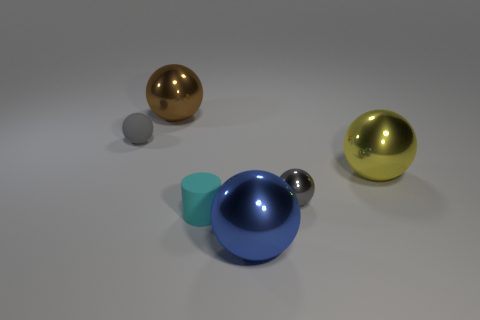There is a metallic ball that is the same color as the rubber ball; what size is it?
Make the answer very short. Small. Are there fewer big yellow metal spheres than small gray shiny cylinders?
Your answer should be compact. No. There is a metal object that is behind the object that is left of the brown sphere; are there any gray matte objects that are right of it?
Give a very brief answer. No. What number of metal objects are tiny cyan cubes or large things?
Give a very brief answer. 3. Do the rubber ball and the small metal sphere have the same color?
Make the answer very short. Yes. How many yellow metallic objects are on the left side of the big yellow thing?
Ensure brevity in your answer.  0. How many metal objects are both to the left of the tiny metal ball and behind the cyan matte cylinder?
Ensure brevity in your answer.  1. There is a gray object that is the same material as the small cyan object; what shape is it?
Keep it short and to the point. Sphere. There is a gray sphere that is on the left side of the gray metal ball; is it the same size as the blue sphere that is in front of the cyan thing?
Your answer should be very brief. No. There is a tiny object that is on the right side of the large blue shiny sphere; what is its color?
Keep it short and to the point. Gray. 